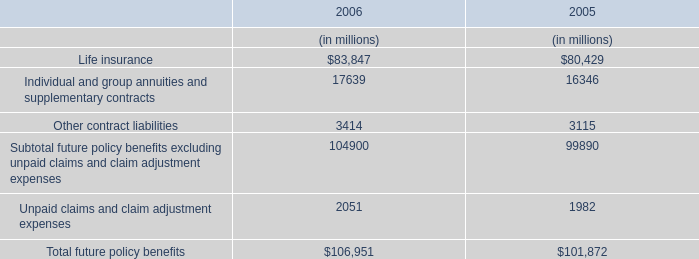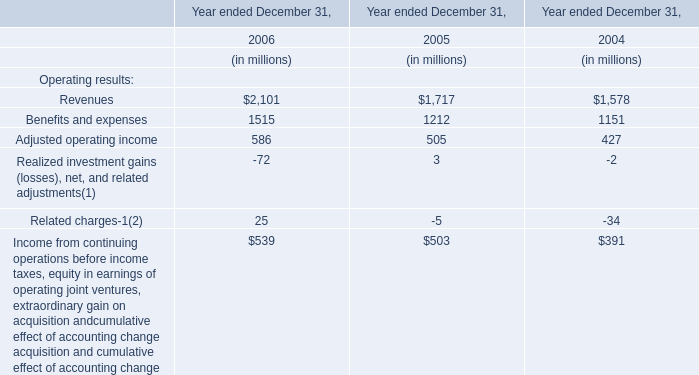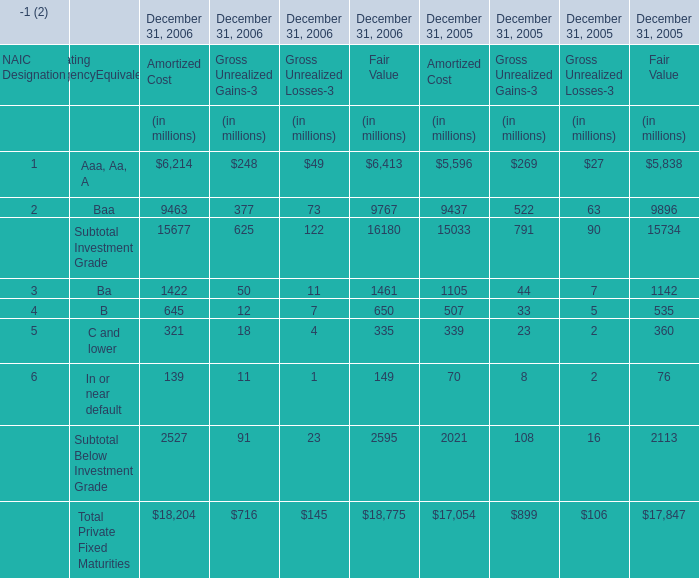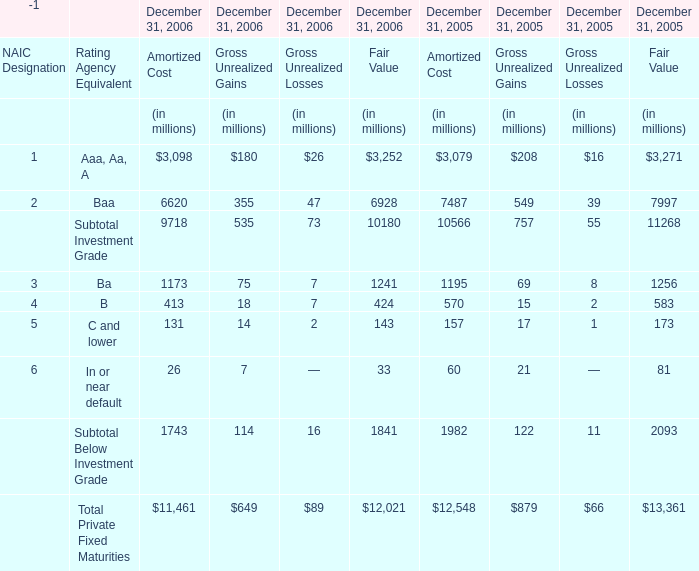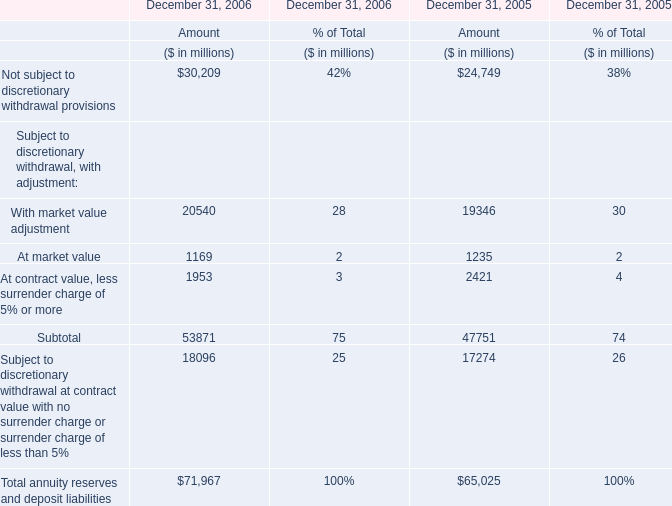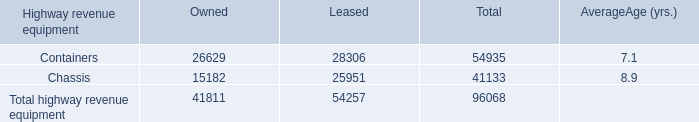What was the average value of the C and lower in the years where Baa is positive? (in million) 
Computations: ((((((((131 + 14) + 2) + 143) + 157) + 17) + 1) + 173) / 2)
Answer: 319.0. 